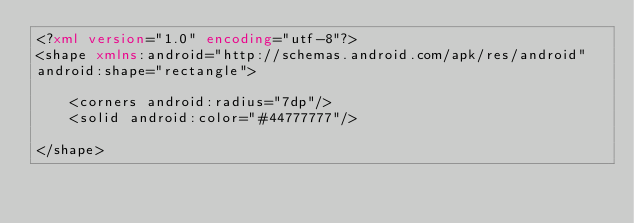Convert code to text. <code><loc_0><loc_0><loc_500><loc_500><_XML_><?xml version="1.0" encoding="utf-8"?>
<shape xmlns:android="http://schemas.android.com/apk/res/android"
android:shape="rectangle">

	<corners android:radius="7dp"/>
	<solid android:color="#44777777"/>

</shape>
</code> 